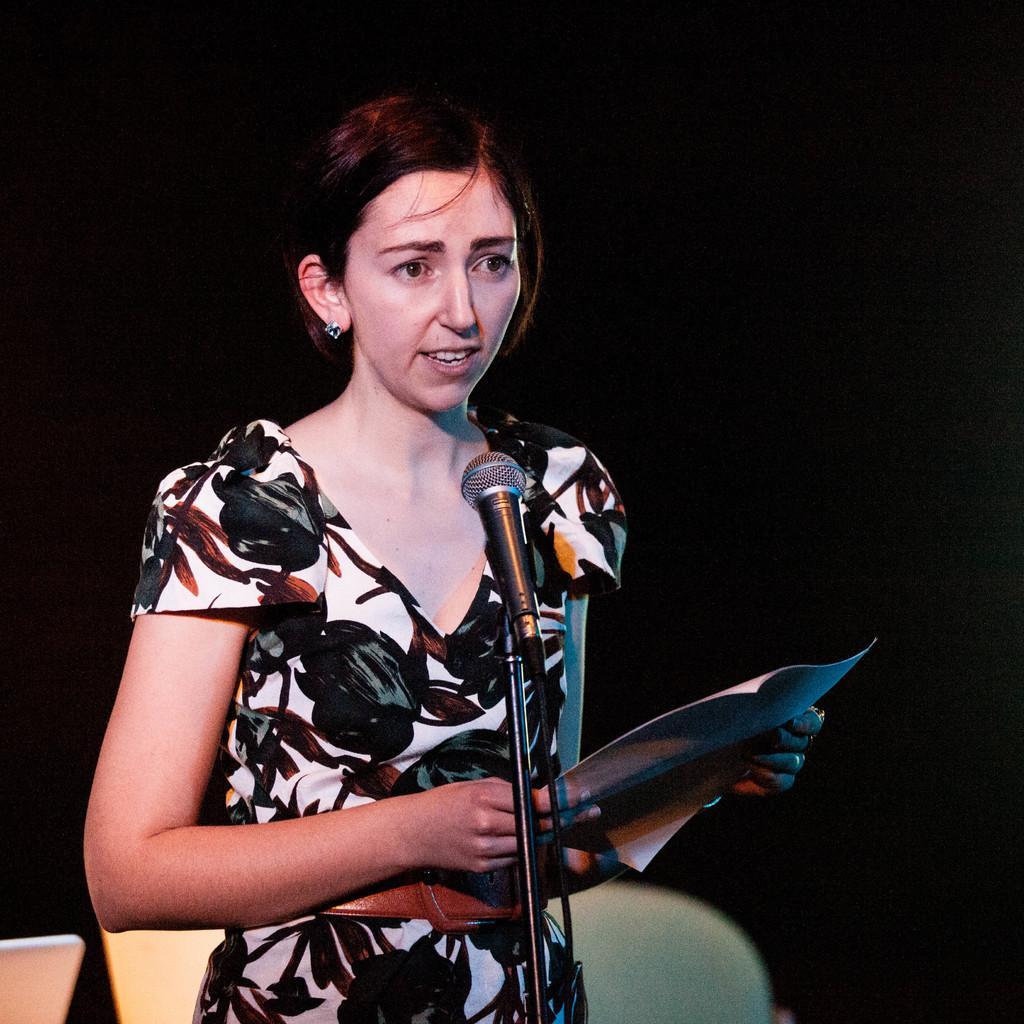Please provide a concise description of this image. In this image there is a lady holding a paper speaking through a microphone, the microphone is attached to the stand and a few chairs. 